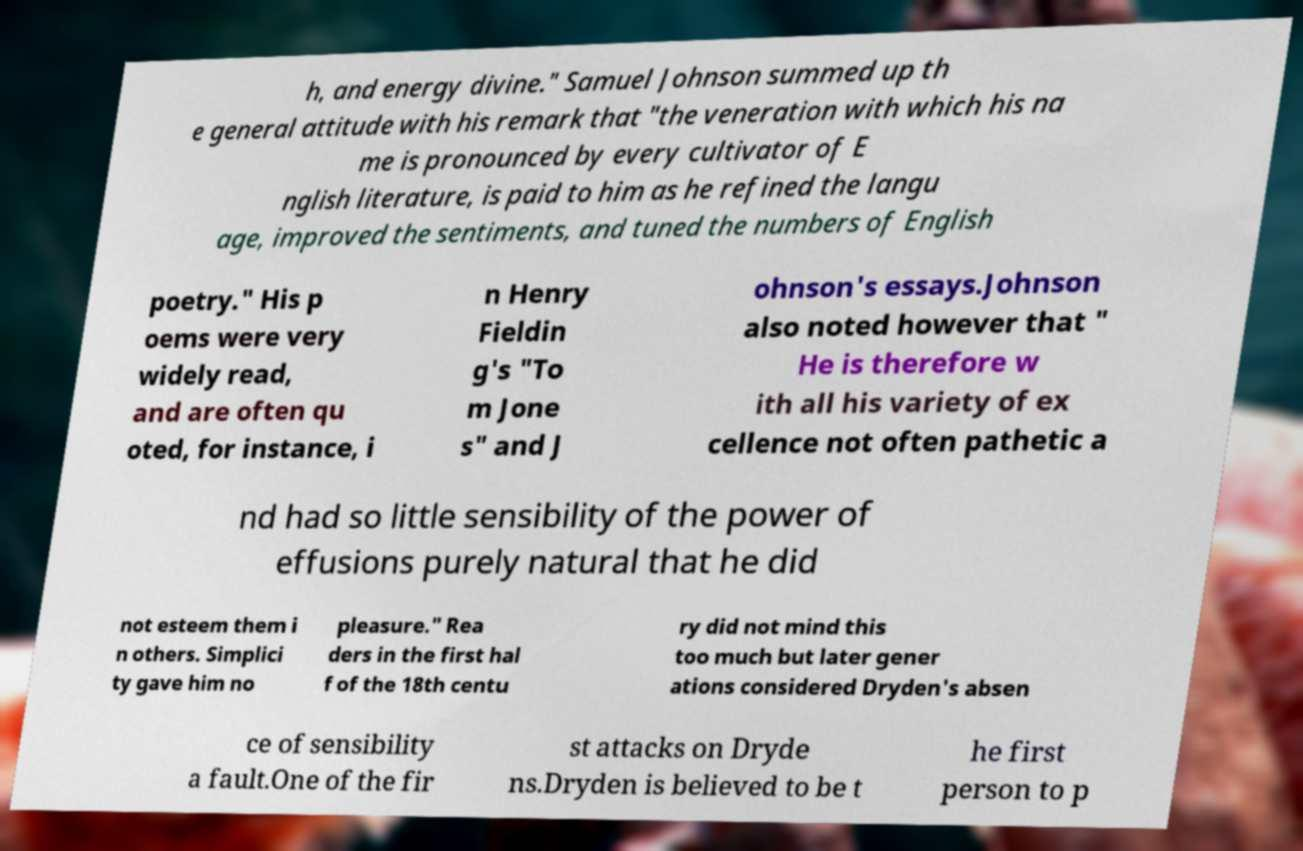For documentation purposes, I need the text within this image transcribed. Could you provide that? h, and energy divine." Samuel Johnson summed up th e general attitude with his remark that "the veneration with which his na me is pronounced by every cultivator of E nglish literature, is paid to him as he refined the langu age, improved the sentiments, and tuned the numbers of English poetry." His p oems were very widely read, and are often qu oted, for instance, i n Henry Fieldin g's "To m Jone s" and J ohnson's essays.Johnson also noted however that " He is therefore w ith all his variety of ex cellence not often pathetic a nd had so little sensibility of the power of effusions purely natural that he did not esteem them i n others. Simplici ty gave him no pleasure." Rea ders in the first hal f of the 18th centu ry did not mind this too much but later gener ations considered Dryden's absen ce of sensibility a fault.One of the fir st attacks on Dryde ns.Dryden is believed to be t he first person to p 